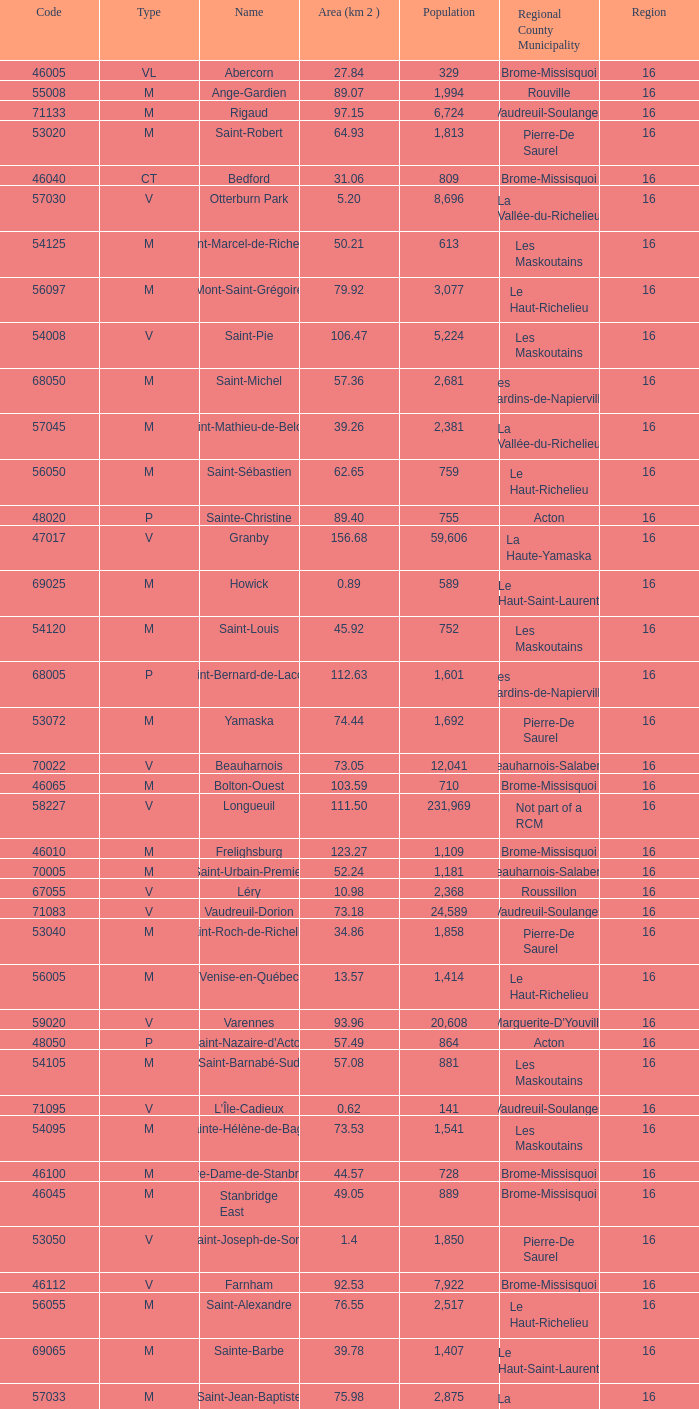What is the code for a Le Haut-Saint-Laurent municipality that has 16 or more regions? None. 